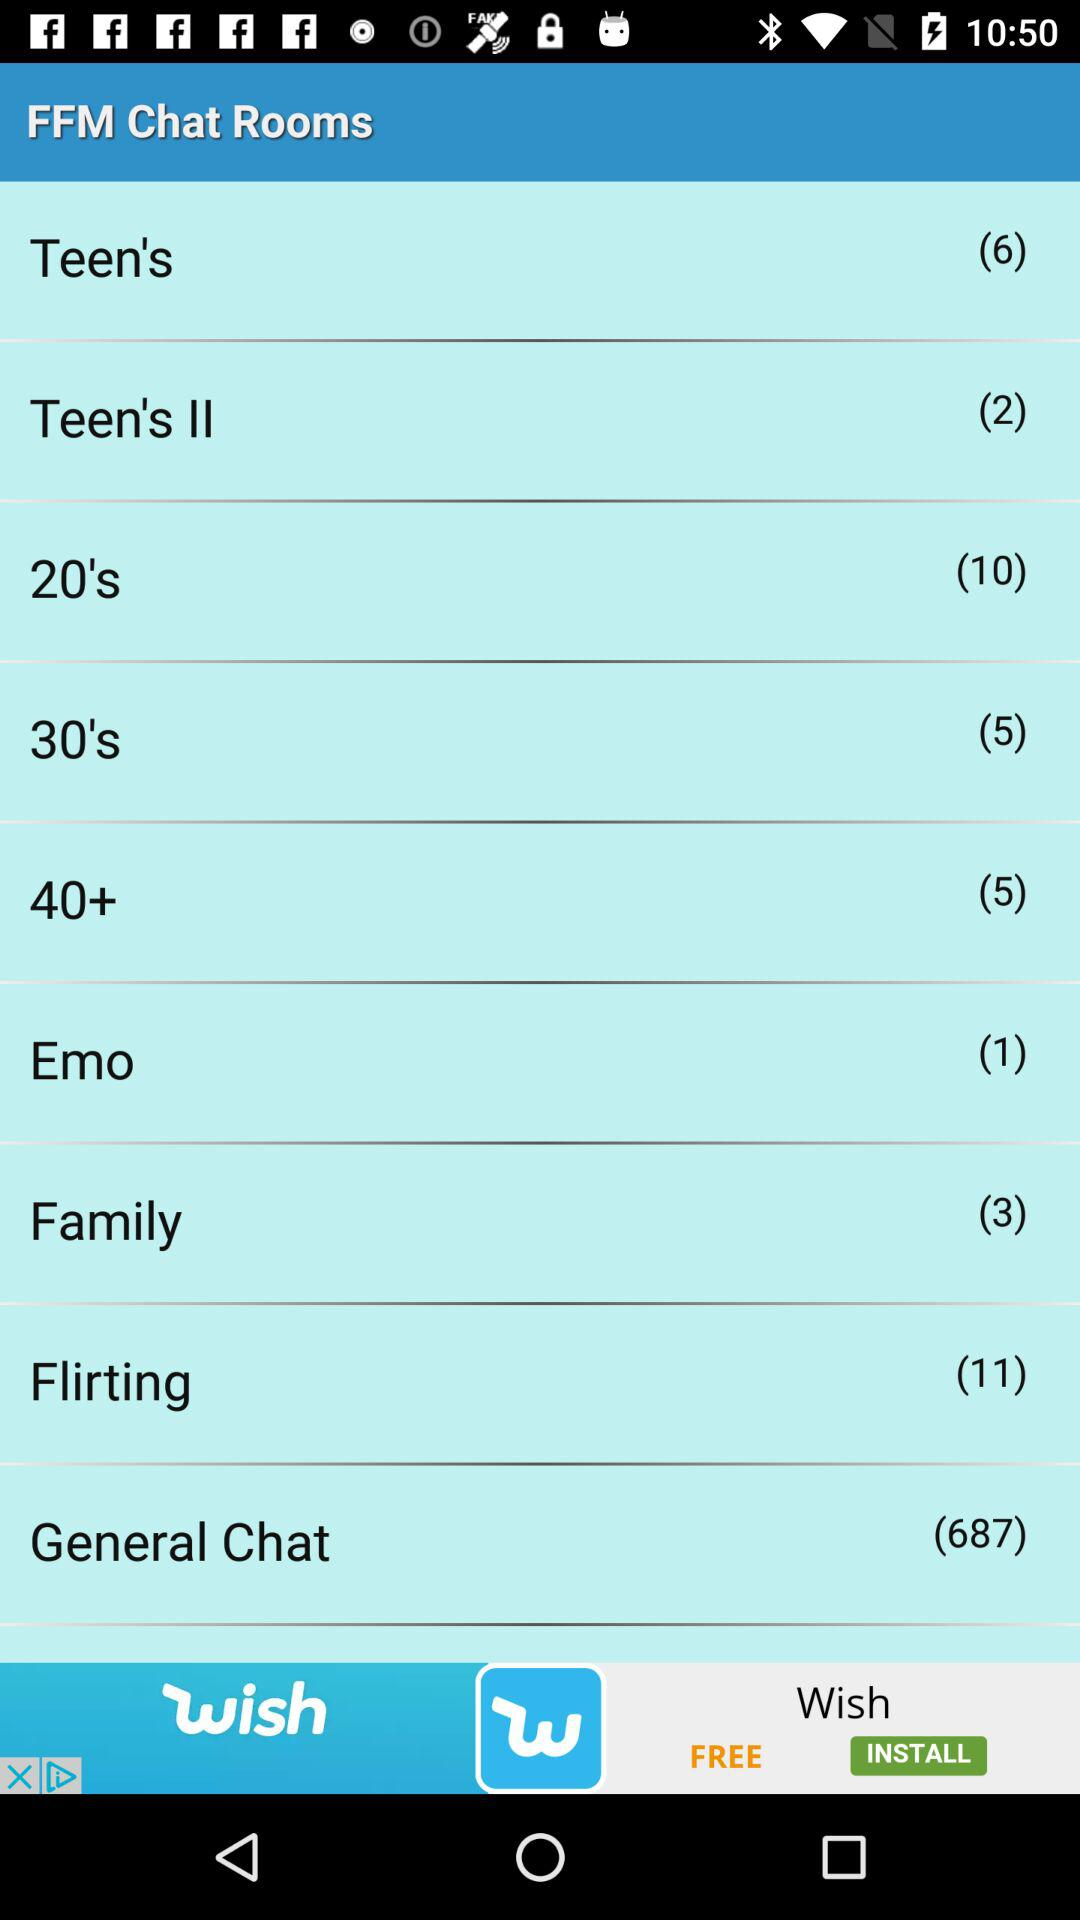How many chat rooms are there in total? There are a total of 7 chat rooms displayed in the list on the screen. These include categories for different age groups and interests, such as 'Teens', '20's', '40+', 'Family', 'Emo', 'Flirting', and a 'General Chat' room. 